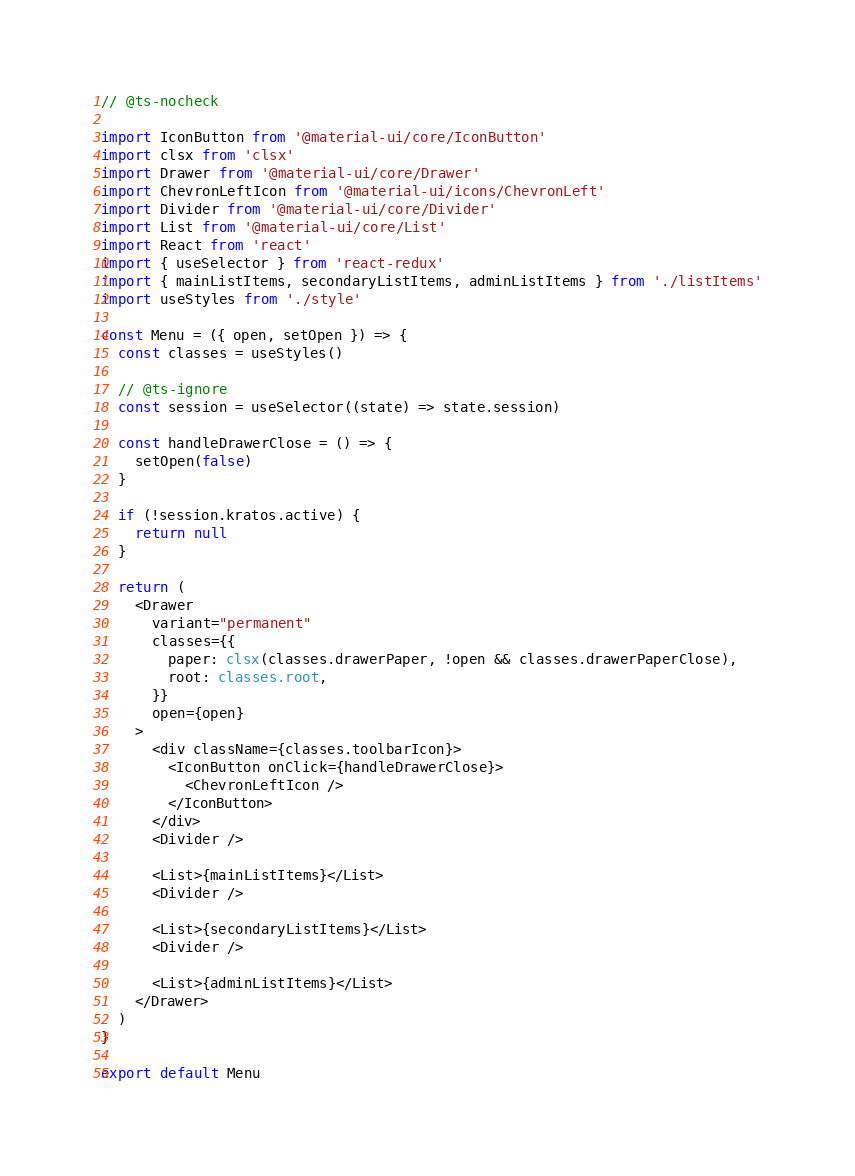<code> <loc_0><loc_0><loc_500><loc_500><_TypeScript_>// @ts-nocheck

import IconButton from '@material-ui/core/IconButton'
import clsx from 'clsx'
import Drawer from '@material-ui/core/Drawer'
import ChevronLeftIcon from '@material-ui/icons/ChevronLeft'
import Divider from '@material-ui/core/Divider'
import List from '@material-ui/core/List'
import React from 'react'
import { useSelector } from 'react-redux'
import { mainListItems, secondaryListItems, adminListItems } from './listItems'
import useStyles from './style'

const Menu = ({ open, setOpen }) => {
  const classes = useStyles()

  // @ts-ignore
  const session = useSelector((state) => state.session)

  const handleDrawerClose = () => {
    setOpen(false)
  }

  if (!session.kratos.active) {
    return null
  }

  return (
    <Drawer
      variant="permanent"
      classes={{
        paper: clsx(classes.drawerPaper, !open && classes.drawerPaperClose),
        root: classes.root,
      }}
      open={open}
    >
      <div className={classes.toolbarIcon}>
        <IconButton onClick={handleDrawerClose}>
          <ChevronLeftIcon />
        </IconButton>
      </div>
      <Divider />

      <List>{mainListItems}</List>
      <Divider />

      <List>{secondaryListItems}</List>
      <Divider />

      <List>{adminListItems}</List>
    </Drawer>
  )
}

export default Menu
</code> 